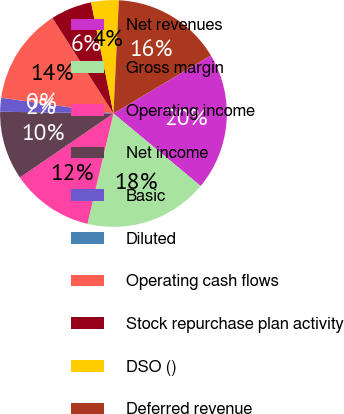Convert chart to OTSL. <chart><loc_0><loc_0><loc_500><loc_500><pie_chart><fcel>Net revenues<fcel>Gross margin<fcel>Operating income<fcel>Net income<fcel>Basic<fcel>Diluted<fcel>Operating cash flows<fcel>Stock repurchase plan activity<fcel>DSO ()<fcel>Deferred revenue<nl><fcel>19.6%<fcel>17.64%<fcel>11.76%<fcel>9.8%<fcel>1.97%<fcel>0.01%<fcel>13.72%<fcel>5.88%<fcel>3.93%<fcel>15.68%<nl></chart> 